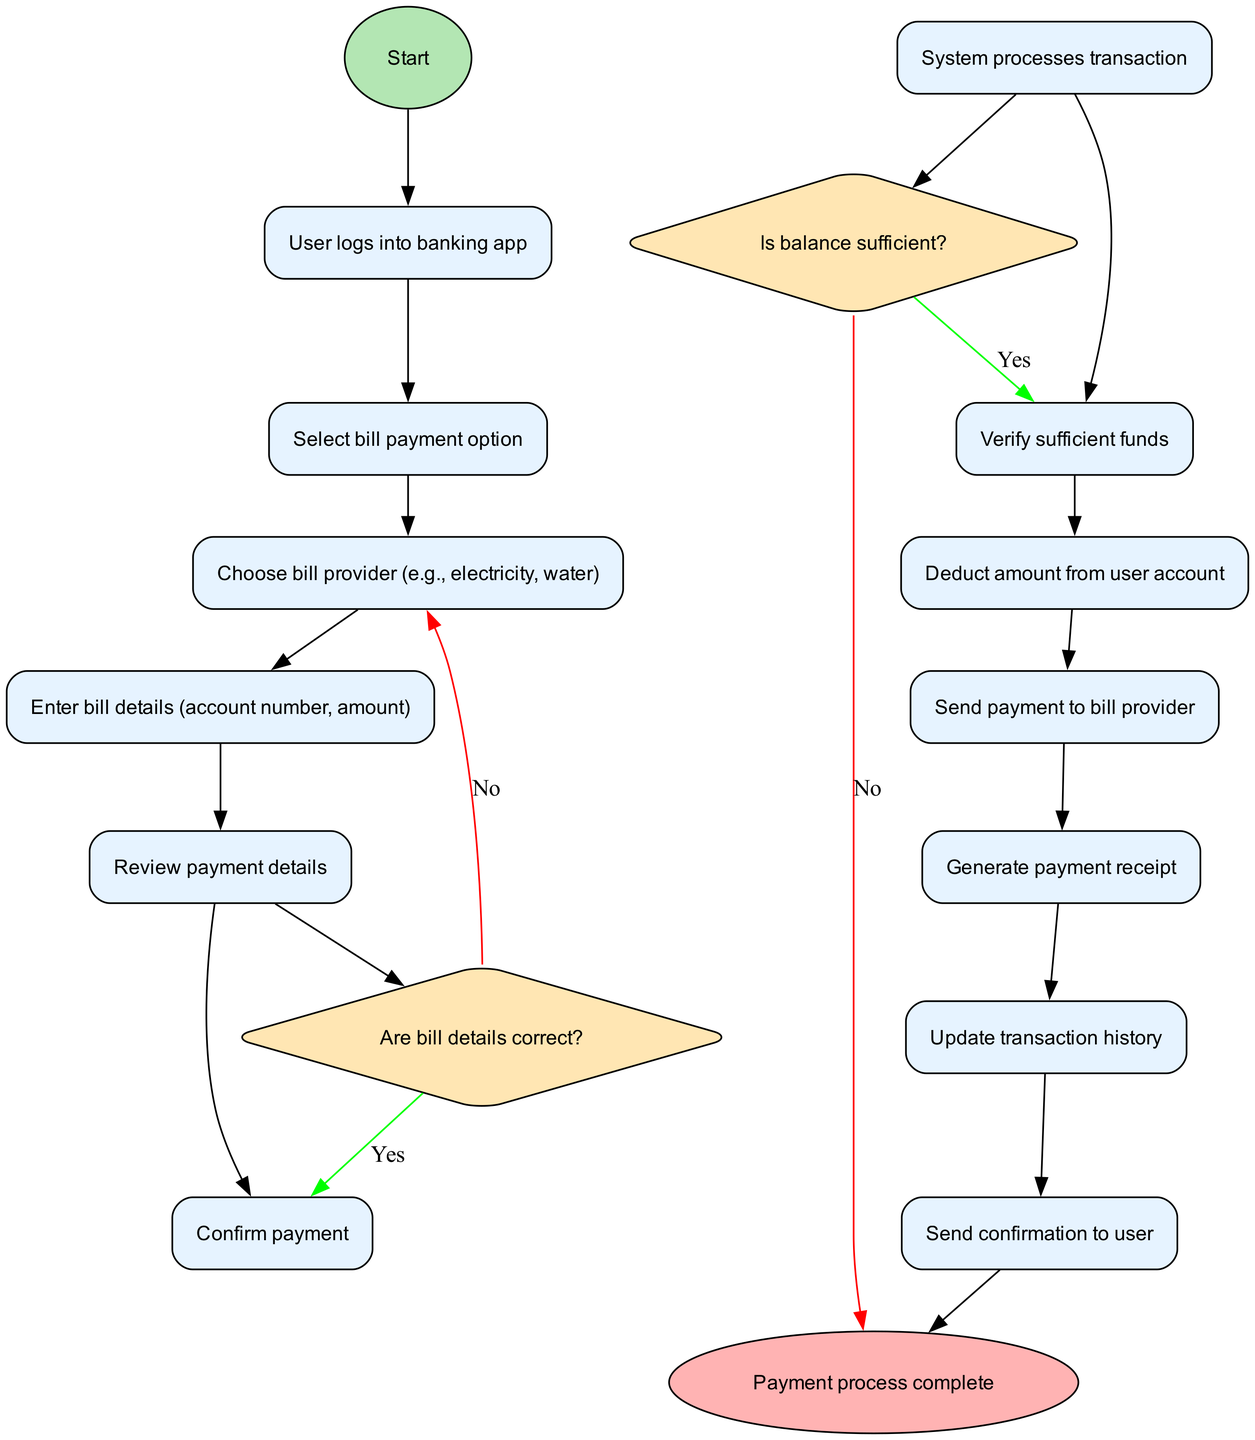What is the first action taken after logging into the banking app? The first action, which is directly connected to the start node, is the user selecting the bill payment option. This flows as the next step after logging in.
Answer: Select bill payment option How many actions are there in total? By counting all the actions listed in the diagram, there are 12 actions. This includes all steps from choosing the bill provider to sending the confirmation to the user after the payment.
Answer: 12 What decision is made after reviewing payment details? The decision made after reviewing the payment details is to check if the bill details are correct, which determines whether to proceed or not.
Answer: Are bill details correct? What happens if the user does not have sufficient funds? If the user does not have sufficient funds, the flow goes to the end node, indicating that the payment process cannot be completed. Therefore, the transaction does not get processed.
Answer: Payment process complete What action is undertaken after confirming the payment? After confirming the payment, the system processes the transaction as the subsequent action in the flow. This step is critical to ensure that the payment is conducted.
Answer: System processes transaction What node represents the completion of the payment process? The completion of the payment process is represented by the end node, which indicates that all necessary actions and decisions have been finalized successfully.
Answer: Payment process complete What happens after generating the payment receipt? After generating the payment receipt, the next action is to update the transaction history, thereby keeping a record of the completed payment in the user's account activity.
Answer: Update transaction history Is there any step that checks if the payment details are correct? Yes, there is a decision node specifically for verifying if the bill details are correct, which should not be bypassed to ensure proper payment processing.
Answer: Are bill details correct? 